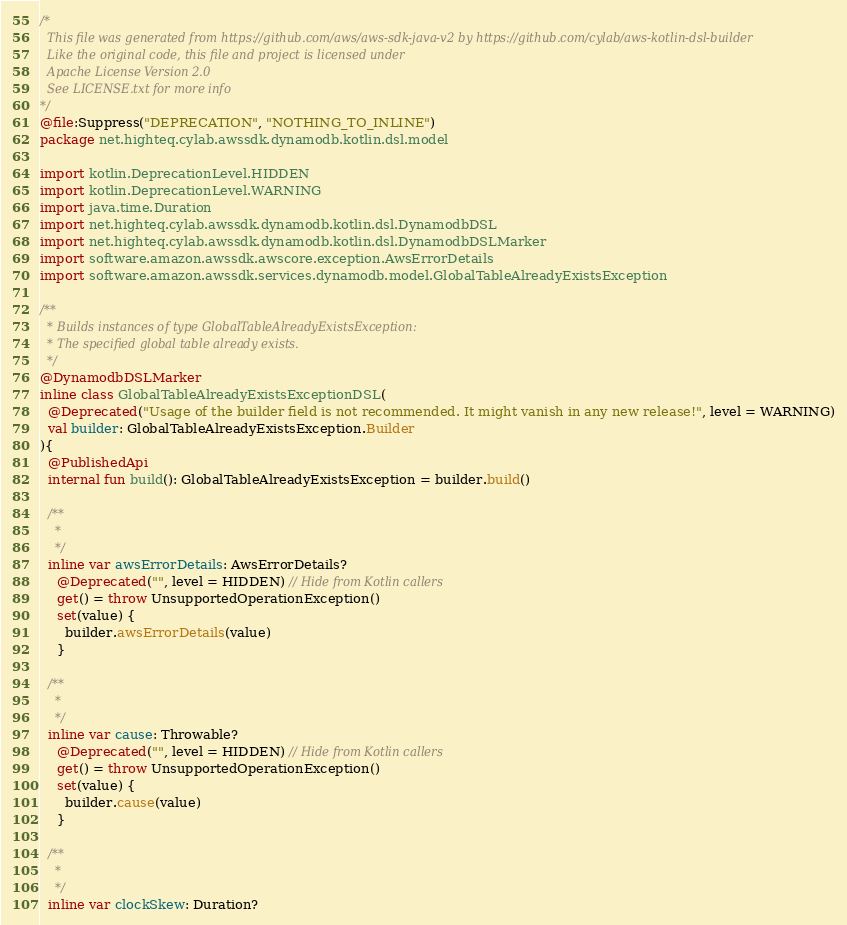Convert code to text. <code><loc_0><loc_0><loc_500><loc_500><_Kotlin_>/*
  This file was generated from https://github.com/aws/aws-sdk-java-v2 by https://github.com/cylab/aws-kotlin-dsl-builder
  Like the original code, this file and project is licensed under
  Apache License Version 2.0
  See LICENSE.txt for more info
*/
@file:Suppress("DEPRECATION", "NOTHING_TO_INLINE")
package net.highteq.cylab.awssdk.dynamodb.kotlin.dsl.model

import kotlin.DeprecationLevel.HIDDEN
import kotlin.DeprecationLevel.WARNING
import java.time.Duration
import net.highteq.cylab.awssdk.dynamodb.kotlin.dsl.DynamodbDSL
import net.highteq.cylab.awssdk.dynamodb.kotlin.dsl.DynamodbDSLMarker
import software.amazon.awssdk.awscore.exception.AwsErrorDetails
import software.amazon.awssdk.services.dynamodb.model.GlobalTableAlreadyExistsException

/**
  * Builds instances of type GlobalTableAlreadyExistsException:
  * The specified global table already exists.
  */
@DynamodbDSLMarker
inline class GlobalTableAlreadyExistsExceptionDSL(
  @Deprecated("Usage of the builder field is not recommended. It might vanish in any new release!", level = WARNING)
  val builder: GlobalTableAlreadyExistsException.Builder
){
  @PublishedApi
  internal fun build(): GlobalTableAlreadyExistsException = builder.build()

  /**
    * 
    */
  inline var awsErrorDetails: AwsErrorDetails?
    @Deprecated("", level = HIDDEN) // Hide from Kotlin callers
    get() = throw UnsupportedOperationException()
    set(value) {
      builder.awsErrorDetails(value)
    }

  /**
    * 
    */
  inline var cause: Throwable?
    @Deprecated("", level = HIDDEN) // Hide from Kotlin callers
    get() = throw UnsupportedOperationException()
    set(value) {
      builder.cause(value)
    }

  /**
    * 
    */
  inline var clockSkew: Duration?</code> 